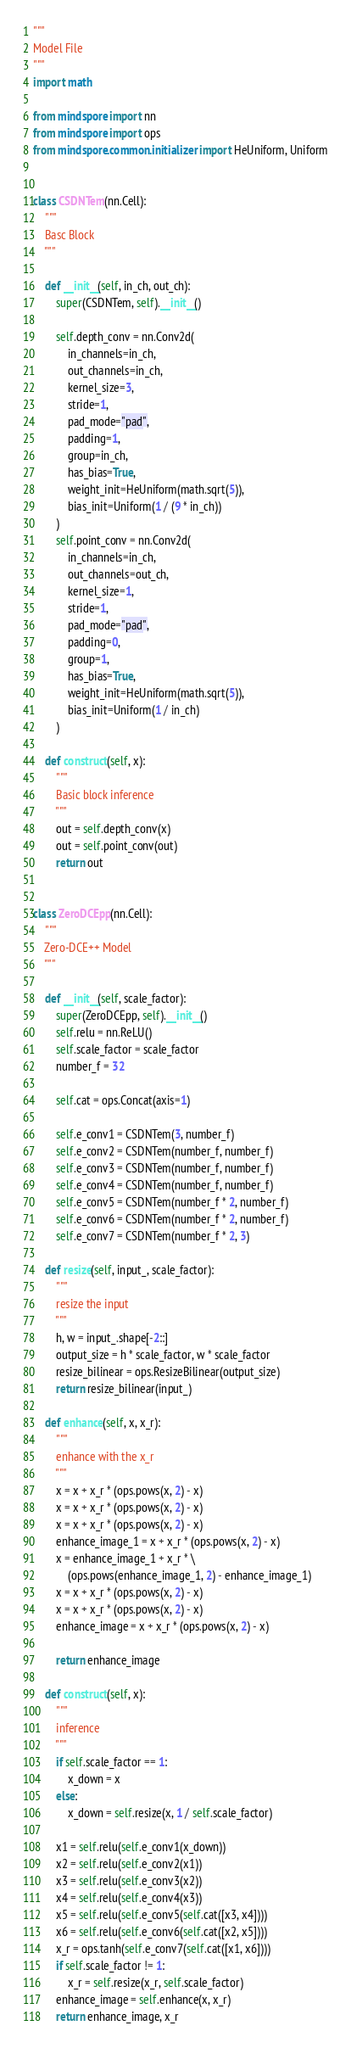Convert code to text. <code><loc_0><loc_0><loc_500><loc_500><_Python_>"""
Model File
"""
import math

from mindspore import nn
from mindspore import ops
from mindspore.common.initializer import HeUniform, Uniform


class CSDNTem(nn.Cell):
    """
    Basc Block
    """

    def __init__(self, in_ch, out_ch):
        super(CSDNTem, self).__init__()

        self.depth_conv = nn.Conv2d(
            in_channels=in_ch,
            out_channels=in_ch,
            kernel_size=3,
            stride=1,
            pad_mode="pad",
            padding=1,
            group=in_ch,
            has_bias=True,
            weight_init=HeUniform(math.sqrt(5)),
            bias_init=Uniform(1 / (9 * in_ch))
        )
        self.point_conv = nn.Conv2d(
            in_channels=in_ch,
            out_channels=out_ch,
            kernel_size=1,
            stride=1,
            pad_mode="pad",
            padding=0,
            group=1,
            has_bias=True,
            weight_init=HeUniform(math.sqrt(5)),
            bias_init=Uniform(1 / in_ch)
        )

    def construct(self, x):
        """
        Basic block inference
        """
        out = self.depth_conv(x)
        out = self.point_conv(out)
        return out


class ZeroDCEpp(nn.Cell):
    """
    Zero-DCE++ Model
    """

    def __init__(self, scale_factor):
        super(ZeroDCEpp, self).__init__()
        self.relu = nn.ReLU()
        self.scale_factor = scale_factor
        number_f = 32

        self.cat = ops.Concat(axis=1)

        self.e_conv1 = CSDNTem(3, number_f)
        self.e_conv2 = CSDNTem(number_f, number_f)
        self.e_conv3 = CSDNTem(number_f, number_f)
        self.e_conv4 = CSDNTem(number_f, number_f)
        self.e_conv5 = CSDNTem(number_f * 2, number_f)
        self.e_conv6 = CSDNTem(number_f * 2, number_f)
        self.e_conv7 = CSDNTem(number_f * 2, 3)

    def resize(self, input_, scale_factor):
        """
        resize the input
        """
        h, w = input_.shape[-2::]
        output_size = h * scale_factor, w * scale_factor
        resize_bilinear = ops.ResizeBilinear(output_size)
        return resize_bilinear(input_)

    def enhance(self, x, x_r):
        """
        enhance with the x_r
        """
        x = x + x_r * (ops.pows(x, 2) - x)
        x = x + x_r * (ops.pows(x, 2) - x)
        x = x + x_r * (ops.pows(x, 2) - x)
        enhance_image_1 = x + x_r * (ops.pows(x, 2) - x)
        x = enhance_image_1 + x_r * \
            (ops.pows(enhance_image_1, 2) - enhance_image_1)
        x = x + x_r * (ops.pows(x, 2) - x)
        x = x + x_r * (ops.pows(x, 2) - x)
        enhance_image = x + x_r * (ops.pows(x, 2) - x)

        return enhance_image

    def construct(self, x):
        """
        inference
        """
        if self.scale_factor == 1:
            x_down = x
        else:
            x_down = self.resize(x, 1 / self.scale_factor)

        x1 = self.relu(self.e_conv1(x_down))
        x2 = self.relu(self.e_conv2(x1))
        x3 = self.relu(self.e_conv3(x2))
        x4 = self.relu(self.e_conv4(x3))
        x5 = self.relu(self.e_conv5(self.cat([x3, x4])))
        x6 = self.relu(self.e_conv6(self.cat([x2, x5])))
        x_r = ops.tanh(self.e_conv7(self.cat([x1, x6])))
        if self.scale_factor != 1:
            x_r = self.resize(x_r, self.scale_factor)
        enhance_image = self.enhance(x, x_r)
        return enhance_image, x_r
</code> 